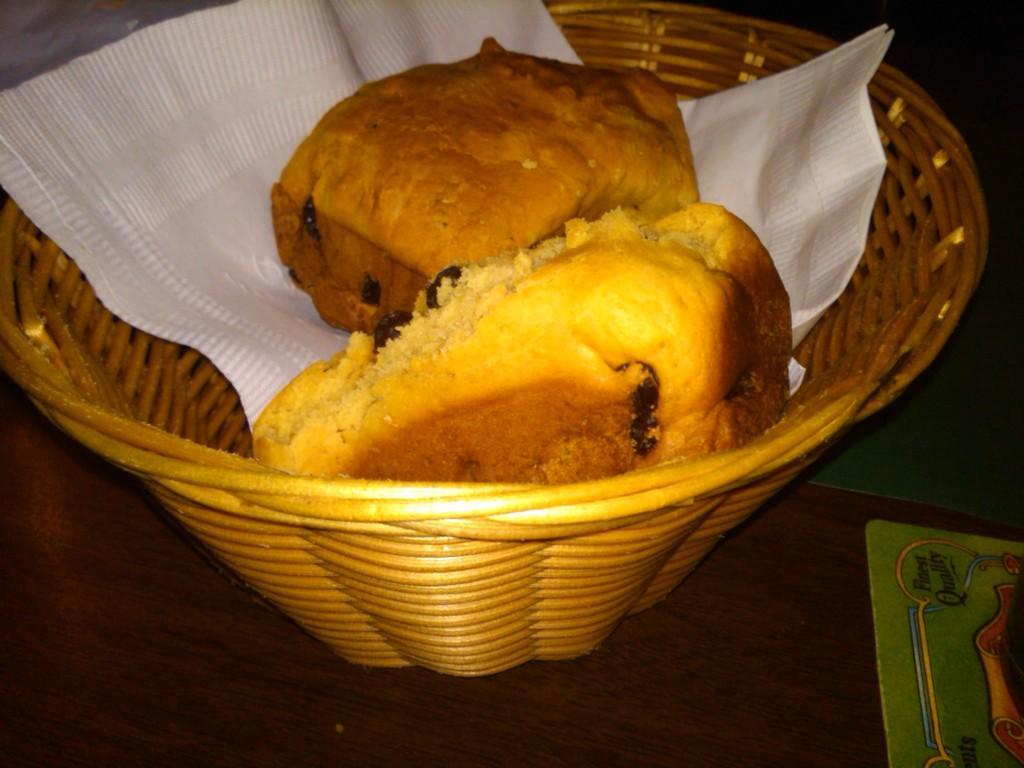In one or two sentences, can you explain what this image depicts? These are the buns in the basket, this is the white color tissue. 